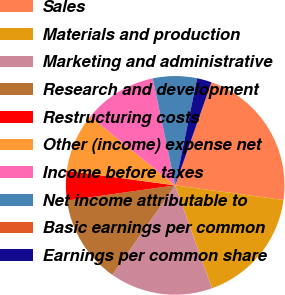Convert chart to OTSL. <chart><loc_0><loc_0><loc_500><loc_500><pie_chart><fcel>Sales<fcel>Materials and production<fcel>Marketing and administrative<fcel>Research and development<fcel>Restructuring costs<fcel>Other (income) expense net<fcel>Income before taxes<fcel>Net income attributable to<fcel>Basic earnings per common<fcel>Earnings per common share<nl><fcel>21.74%<fcel>17.39%<fcel>15.22%<fcel>13.04%<fcel>4.35%<fcel>8.7%<fcel>10.87%<fcel>6.52%<fcel>0.0%<fcel>2.17%<nl></chart> 